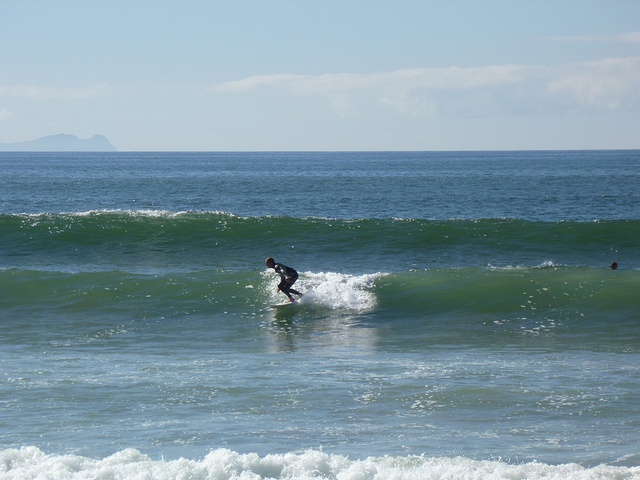Describe the objects in this image and their specific colors. I can see people in lightblue, black, gray, navy, and darkgray tones, surfboard in lightblue, gray, darkgray, lightgray, and teal tones, and people in lightblue, black, gray, maroon, and teal tones in this image. 